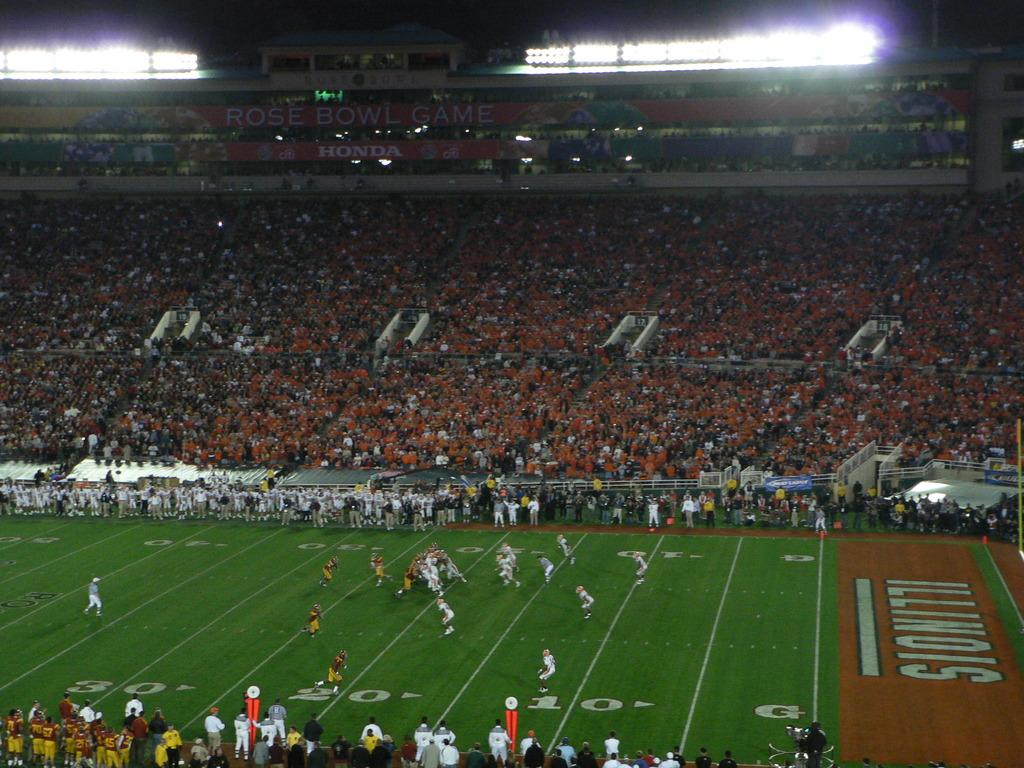Provide a one-sentence caption for the provided image. College Football game presented by the Illinois home team. 